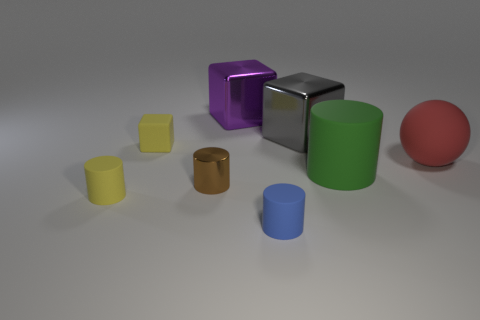Subtract all large purple metal cubes. How many cubes are left? 2 Subtract all purple blocks. How many blocks are left? 2 Add 1 green rubber things. How many objects exist? 9 Subtract all cubes. How many objects are left? 5 Subtract 3 cubes. How many cubes are left? 0 Subtract 0 brown blocks. How many objects are left? 8 Subtract all purple cylinders. Subtract all blue blocks. How many cylinders are left? 4 Subtract all metal objects. Subtract all large brown shiny spheres. How many objects are left? 5 Add 8 tiny blue cylinders. How many tiny blue cylinders are left? 9 Add 4 large gray things. How many large gray things exist? 5 